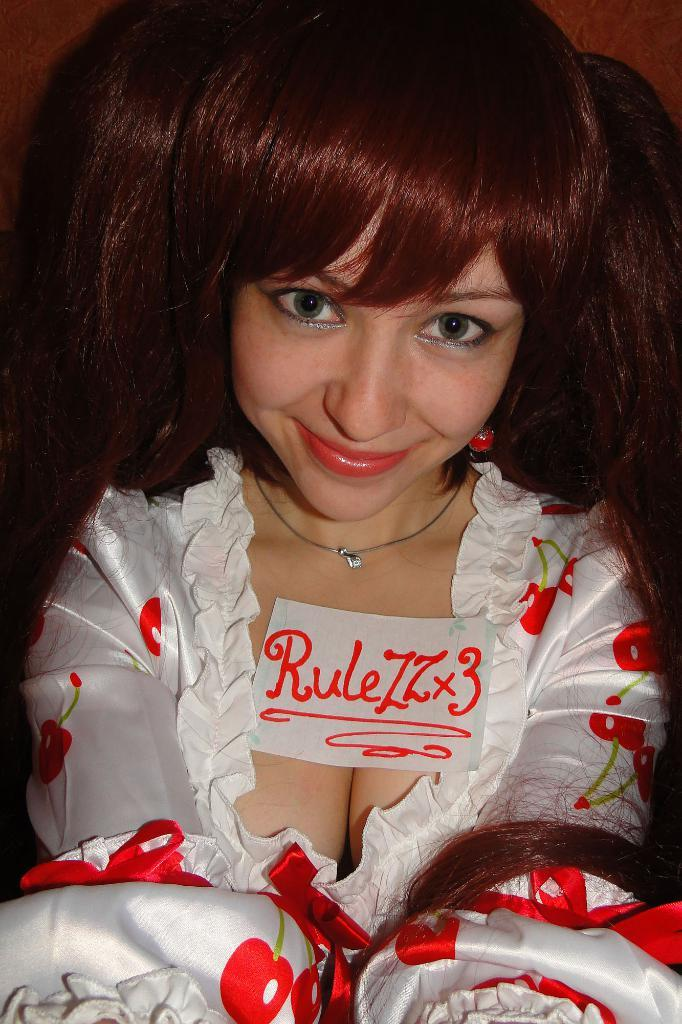Who is the main subject in the image? There is a lady in the image. What is the lady wearing? The lady is wearing a white and red color dress. Can you describe any accessories the lady is wearing? The lady has a chain around her neck. What is the lady's facial expression? The lady is smiling. What is the lady holding or standing near? There is a paper with something written on it below her neck. Can you describe the lake in the background of the image? There is no lake present in the image; it features a lady wearing a dress and holding a paper. What type of haircut does the lady have in the image? The provided facts do not mention the lady's haircut, so it cannot be determined from the image. 